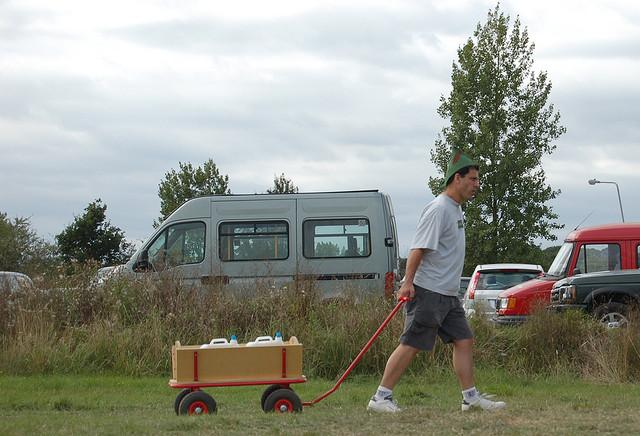What color is the main body of the cart pulled by this guy? Please explain your reasoning. wood. The beige brown color of the cart being pulled identifies it as wood. 